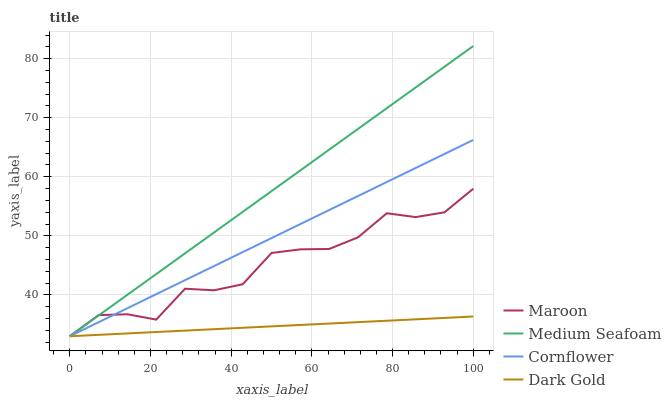Does Dark Gold have the minimum area under the curve?
Answer yes or no. Yes. Does Medium Seafoam have the maximum area under the curve?
Answer yes or no. Yes. Does Maroon have the minimum area under the curve?
Answer yes or no. No. Does Maroon have the maximum area under the curve?
Answer yes or no. No. Is Dark Gold the smoothest?
Answer yes or no. Yes. Is Maroon the roughest?
Answer yes or no. Yes. Is Medium Seafoam the smoothest?
Answer yes or no. No. Is Medium Seafoam the roughest?
Answer yes or no. No. Does Cornflower have the lowest value?
Answer yes or no. Yes. Does Medium Seafoam have the highest value?
Answer yes or no. Yes. Does Maroon have the highest value?
Answer yes or no. No. Does Dark Gold intersect Medium Seafoam?
Answer yes or no. Yes. Is Dark Gold less than Medium Seafoam?
Answer yes or no. No. Is Dark Gold greater than Medium Seafoam?
Answer yes or no. No. 